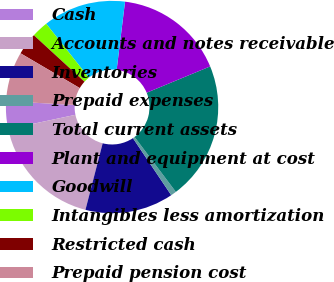<chart> <loc_0><loc_0><loc_500><loc_500><pie_chart><fcel>Cash<fcel>Accounts and notes receivable<fcel>Inventories<fcel>Prepaid expenses<fcel>Total current assets<fcel>Plant and equipment at cost<fcel>Goodwill<fcel>Intangibles less amortization<fcel>Restricted cash<fcel>Prepaid pension cost<nl><fcel>4.21%<fcel>17.64%<fcel>13.44%<fcel>0.85%<fcel>20.99%<fcel>16.8%<fcel>12.6%<fcel>2.53%<fcel>3.37%<fcel>7.57%<nl></chart> 